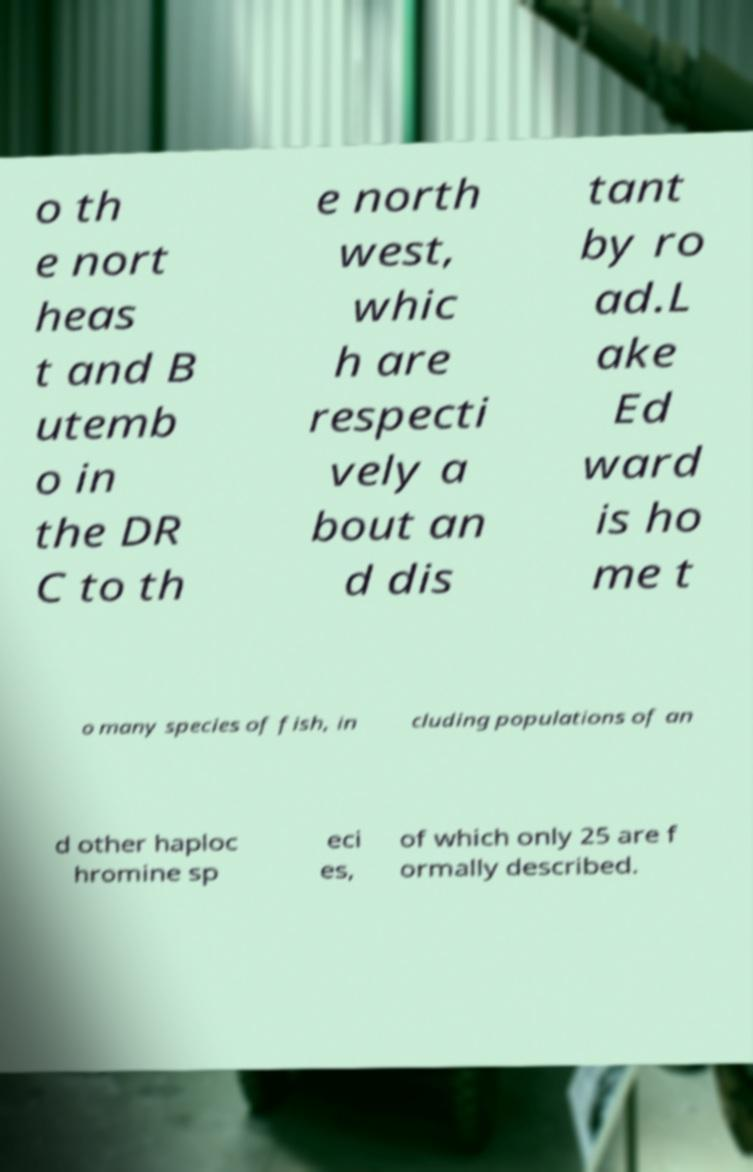Can you read and provide the text displayed in the image?This photo seems to have some interesting text. Can you extract and type it out for me? o th e nort heas t and B utemb o in the DR C to th e north west, whic h are respecti vely a bout an d dis tant by ro ad.L ake Ed ward is ho me t o many species of fish, in cluding populations of an d other haploc hromine sp eci es, of which only 25 are f ormally described. 